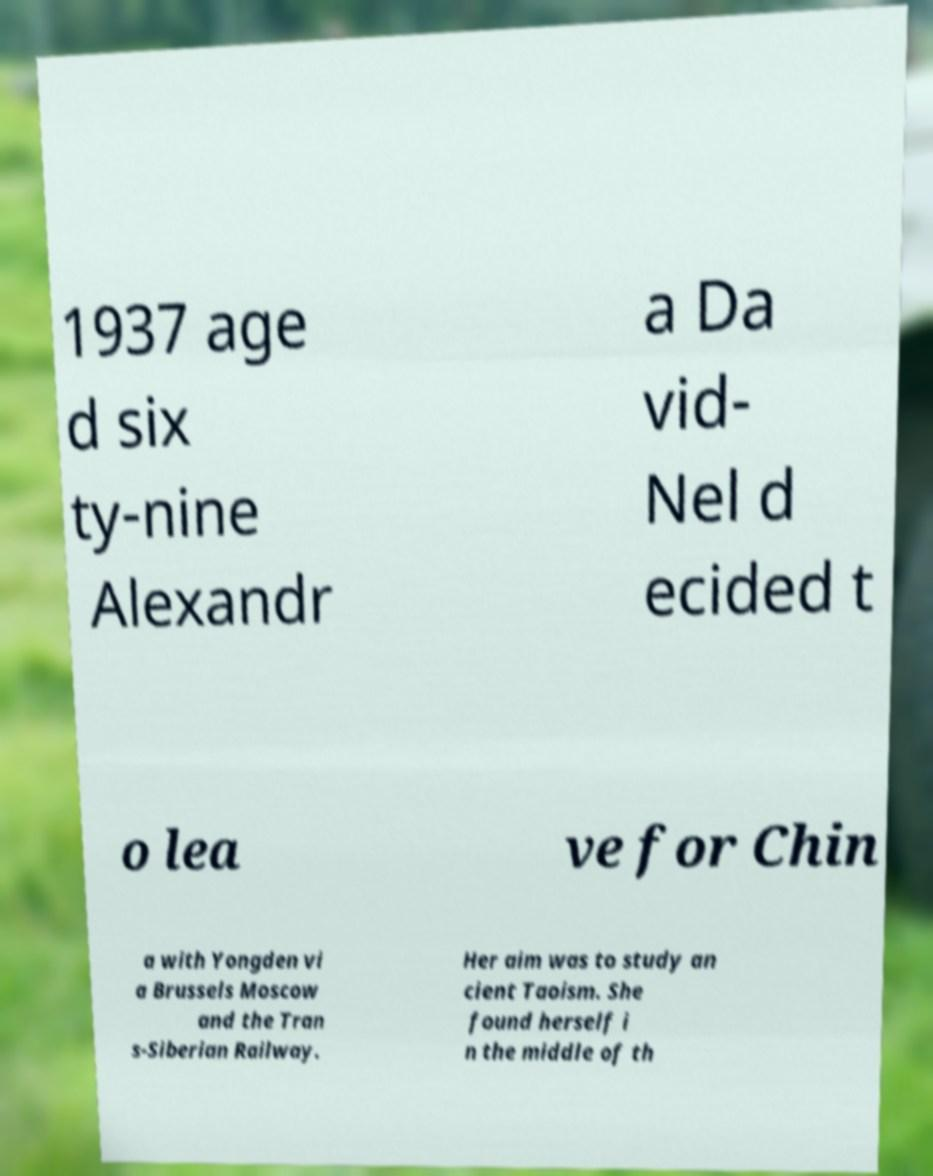For documentation purposes, I need the text within this image transcribed. Could you provide that? 1937 age d six ty-nine Alexandr a Da vid- Nel d ecided t o lea ve for Chin a with Yongden vi a Brussels Moscow and the Tran s-Siberian Railway. Her aim was to study an cient Taoism. She found herself i n the middle of th 